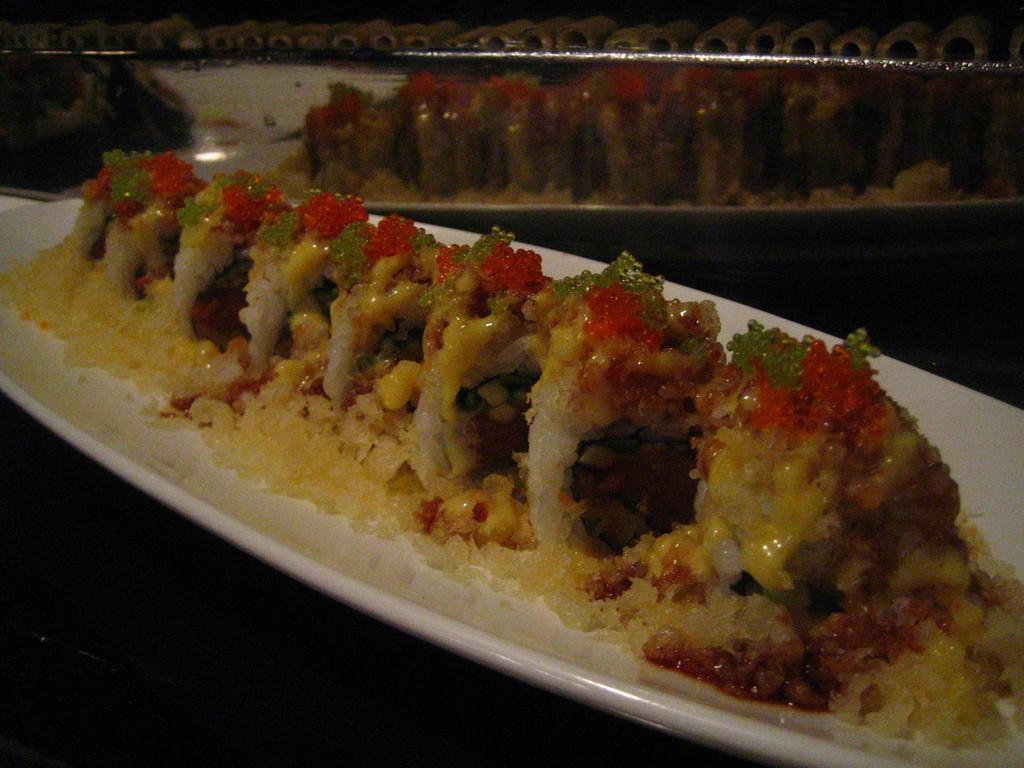What is the main object in the center of the image? There is a plate in the center of the image. What is on the plate? The plate contains food items. How many books are stacked next to the plate in the image? There are no books present in the image. 